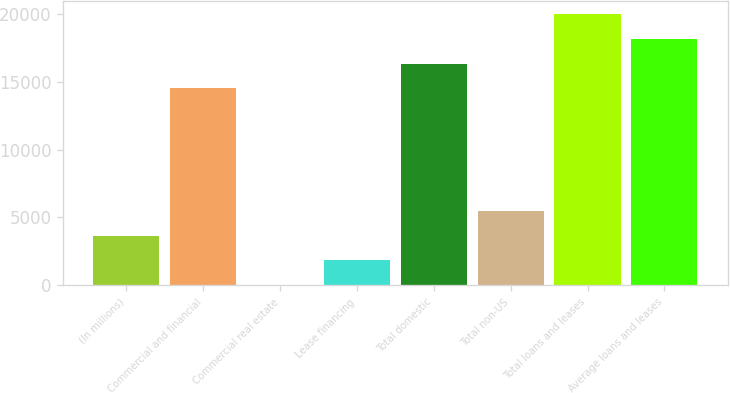Convert chart. <chart><loc_0><loc_0><loc_500><loc_500><bar_chart><fcel>(In millions)<fcel>Commercial and financial<fcel>Commercial real estate<fcel>Lease financing<fcel>Total domestic<fcel>Total non-US<fcel>Total loans and leases<fcel>Average loans and leases<nl><fcel>3662.2<fcel>14515<fcel>28<fcel>1845.1<fcel>16332.1<fcel>5479.3<fcel>19966.3<fcel>18149.2<nl></chart> 